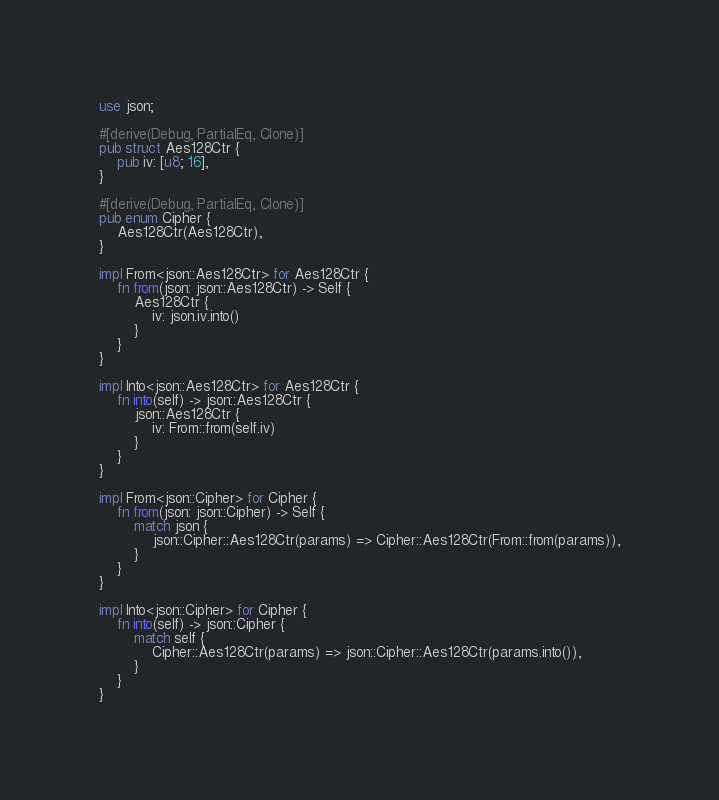<code> <loc_0><loc_0><loc_500><loc_500><_Rust_>
use json;

#[derive(Debug, PartialEq, Clone)]
pub struct Aes128Ctr {
	pub iv: [u8; 16],
}

#[derive(Debug, PartialEq, Clone)]
pub enum Cipher {
	Aes128Ctr(Aes128Ctr),
}

impl From<json::Aes128Ctr> for Aes128Ctr {
	fn from(json: json::Aes128Ctr) -> Self {
		Aes128Ctr {
			iv: json.iv.into()
		}
	}
}

impl Into<json::Aes128Ctr> for Aes128Ctr {
	fn into(self) -> json::Aes128Ctr {
		json::Aes128Ctr {
			iv: From::from(self.iv)
		}
	}
}

impl From<json::Cipher> for Cipher {
	fn from(json: json::Cipher) -> Self {
		match json {
			json::Cipher::Aes128Ctr(params) => Cipher::Aes128Ctr(From::from(params)),
		}
	}
}

impl Into<json::Cipher> for Cipher {
	fn into(self) -> json::Cipher {
		match self {
			Cipher::Aes128Ctr(params) => json::Cipher::Aes128Ctr(params.into()),
		}
	}
}
</code> 